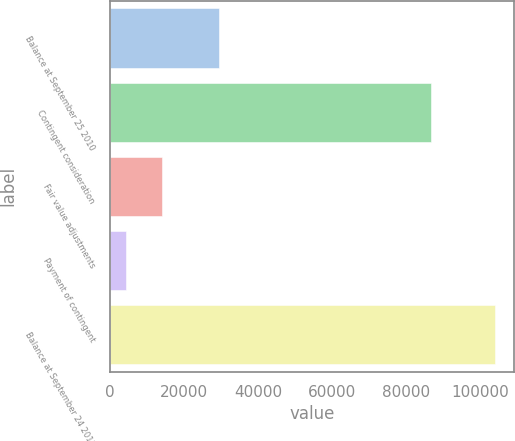Convert chart to OTSL. <chart><loc_0><loc_0><loc_500><loc_500><bar_chart><fcel>Balance at September 25 2010<fcel>Contingent consideration<fcel>Fair value adjustments<fcel>Payment of contingent<fcel>Balance at September 24 2011<nl><fcel>29500<fcel>86600<fcel>14243.6<fcel>4294<fcel>103790<nl></chart> 